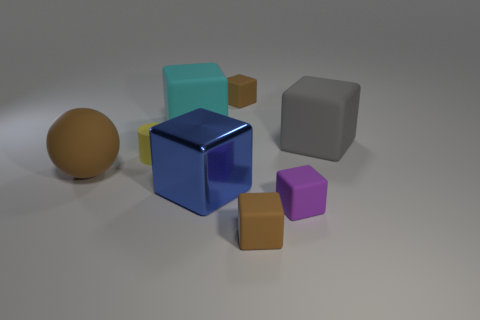There is a big brown thing that is the same material as the yellow cylinder; what is its shape?
Ensure brevity in your answer.  Sphere. What is the material of the big cube that is in front of the large matte thing that is on the right side of the cyan rubber block behind the yellow object?
Your answer should be compact. Metal. Do the blue shiny cube and the brown object on the left side of the yellow rubber object have the same size?
Make the answer very short. Yes. There is a blue object that is the same shape as the large cyan thing; what is its material?
Your answer should be compact. Metal. There is a brown block that is behind the big object to the right of the brown block behind the rubber ball; what size is it?
Make the answer very short. Small. Is the size of the purple thing the same as the brown ball?
Your answer should be compact. No. What is the material of the large thing in front of the brown rubber thing that is on the left side of the big blue block?
Your answer should be very brief. Metal. Does the big matte object that is to the right of the large shiny object have the same shape as the small brown thing behind the gray rubber block?
Offer a terse response. Yes. Is the number of tiny brown matte cubes in front of the gray matte cube the same as the number of tiny blue rubber cylinders?
Your answer should be very brief. No. There is a tiny brown rubber object that is in front of the small purple block; is there a tiny brown rubber thing that is to the right of it?
Provide a short and direct response. No. 